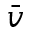<formula> <loc_0><loc_0><loc_500><loc_500>\bar { v }</formula> 